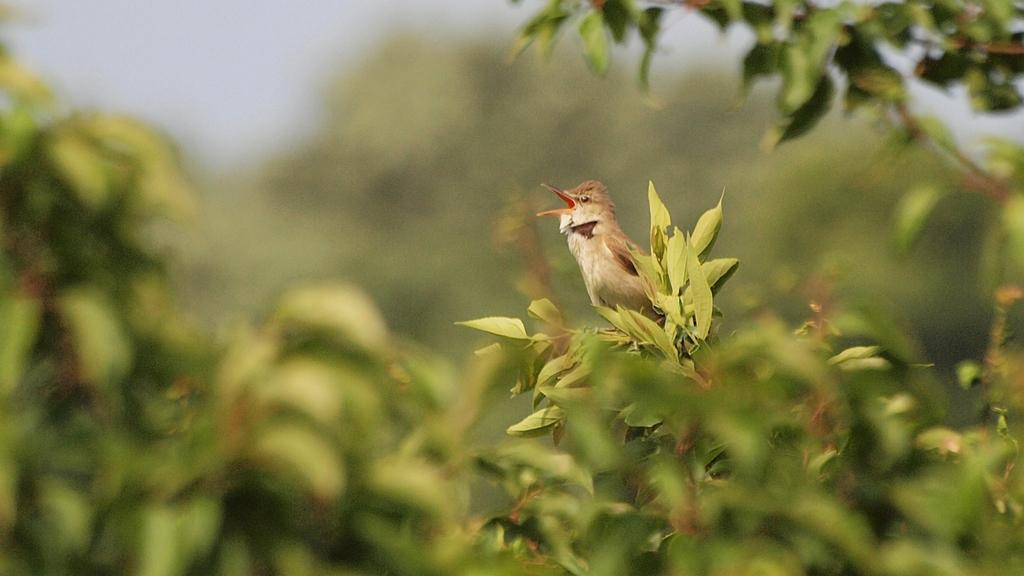What type of animal is present in the image? There is a bird in the image. Where is the bird located? The bird is on a plant. What can be seen in the foreground of the image? There are plants in the foreground of the image. How would you describe the background of the image? The background of the image is blurred. What type of education does the river provide in the image? There is no river present in the image, so it cannot provide any education. 